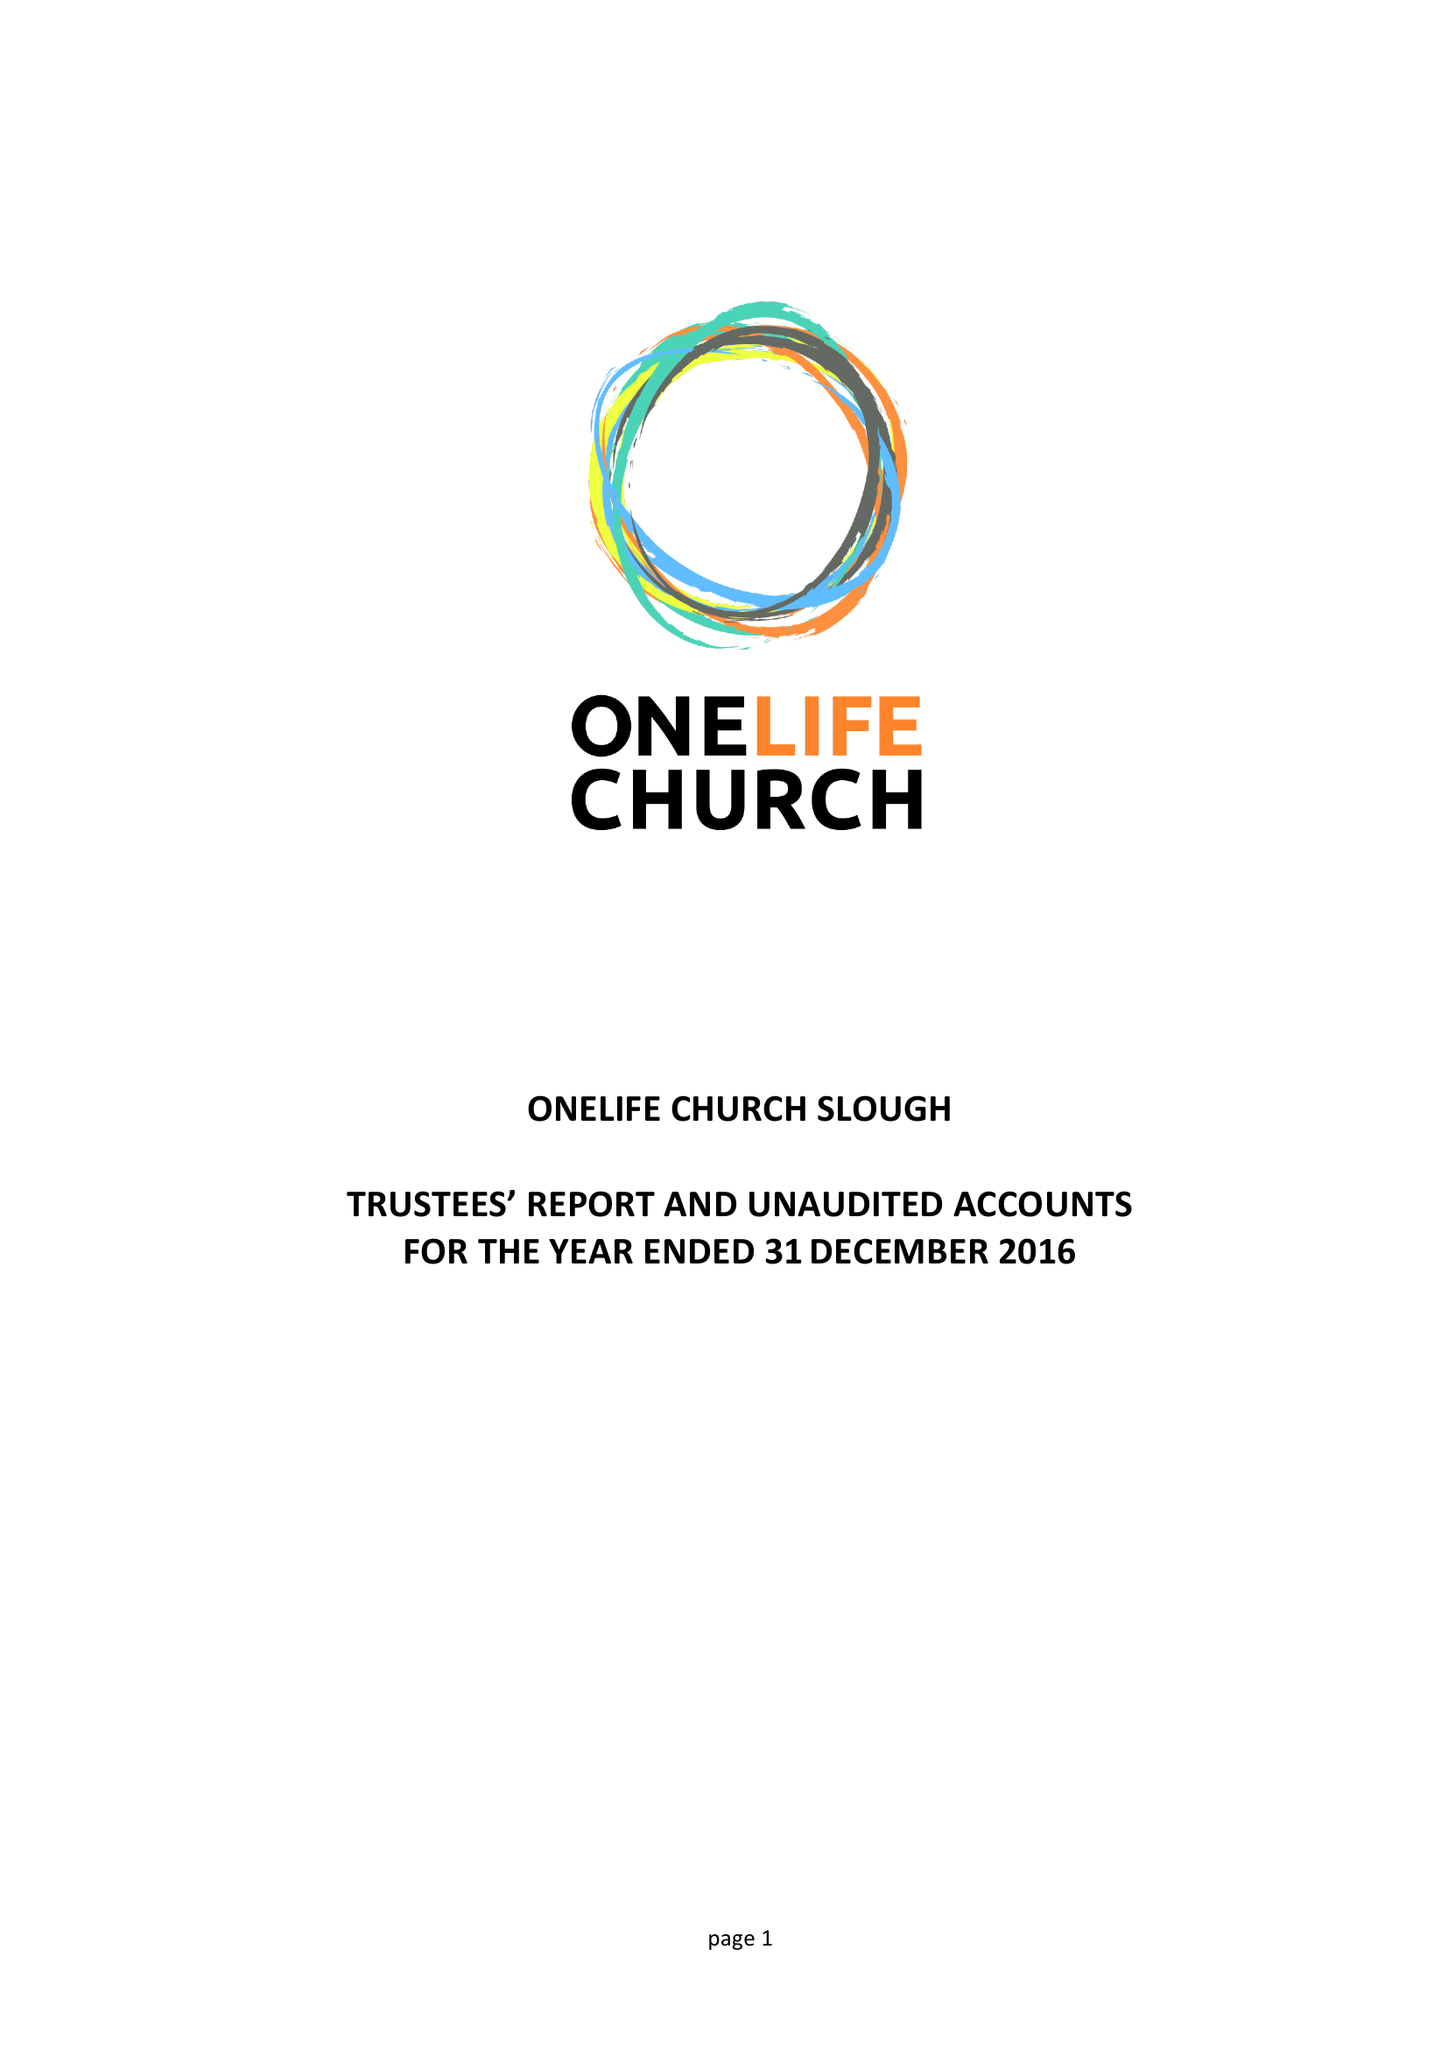What is the value for the address__postcode?
Answer the question using a single word or phrase. SL2 1TY 